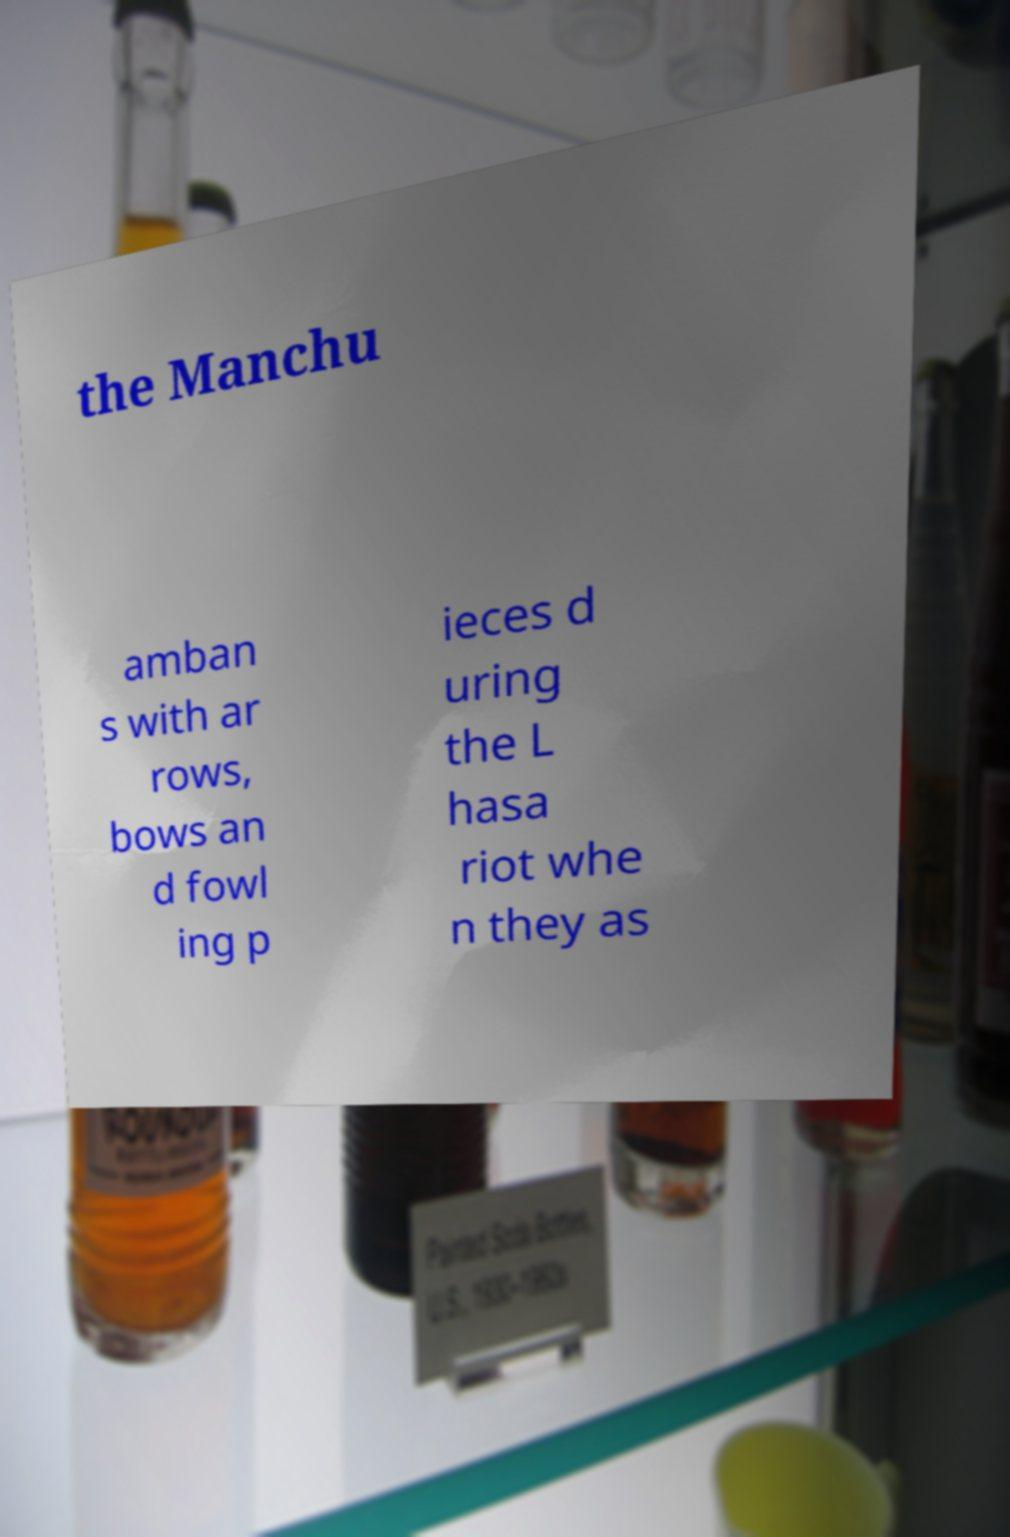Please read and relay the text visible in this image. What does it say? the Manchu amban s with ar rows, bows an d fowl ing p ieces d uring the L hasa riot whe n they as 